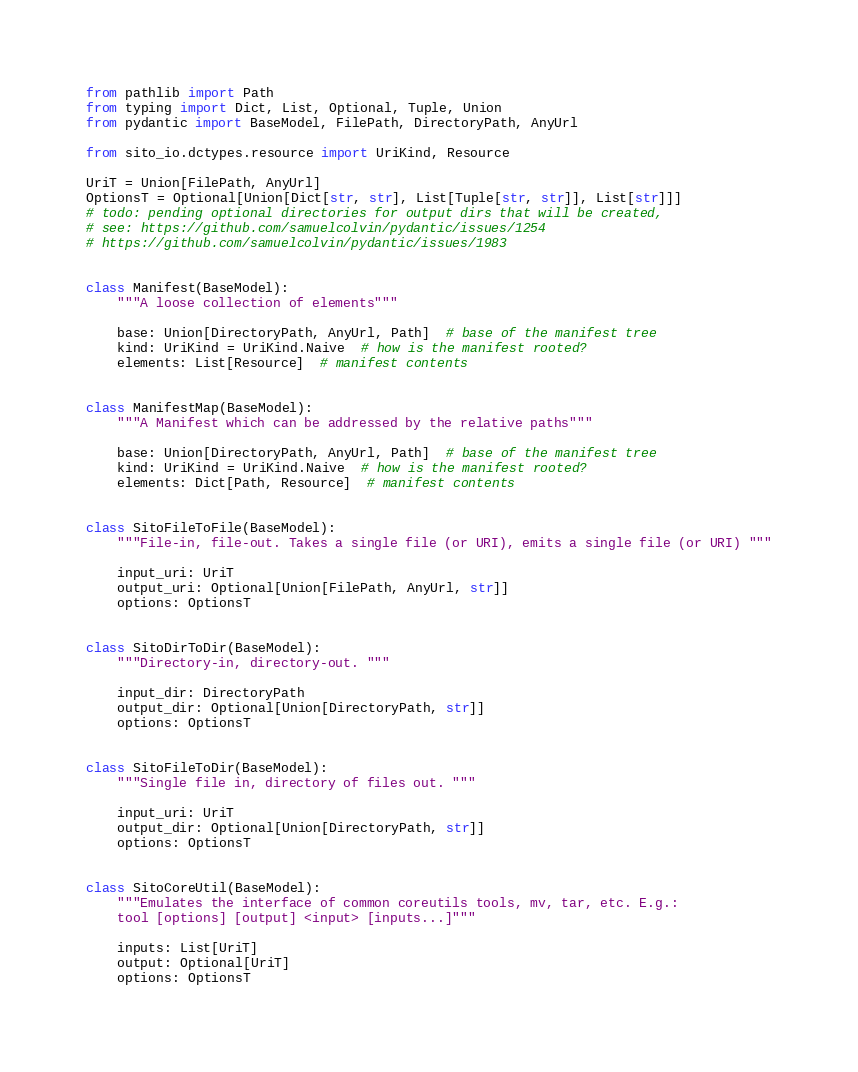Convert code to text. <code><loc_0><loc_0><loc_500><loc_500><_Python_>from pathlib import Path
from typing import Dict, List, Optional, Tuple, Union
from pydantic import BaseModel, FilePath, DirectoryPath, AnyUrl

from sito_io.dctypes.resource import UriKind, Resource

UriT = Union[FilePath, AnyUrl]
OptionsT = Optional[Union[Dict[str, str], List[Tuple[str, str]], List[str]]]
# todo: pending optional directories for output dirs that will be created,
# see: https://github.com/samuelcolvin/pydantic/issues/1254
# https://github.com/samuelcolvin/pydantic/issues/1983


class Manifest(BaseModel):
    """A loose collection of elements"""

    base: Union[DirectoryPath, AnyUrl, Path]  # base of the manifest tree
    kind: UriKind = UriKind.Naive  # how is the manifest rooted?
    elements: List[Resource]  # manifest contents


class ManifestMap(BaseModel):
    """A Manifest which can be addressed by the relative paths"""

    base: Union[DirectoryPath, AnyUrl, Path]  # base of the manifest tree
    kind: UriKind = UriKind.Naive  # how is the manifest rooted?
    elements: Dict[Path, Resource]  # manifest contents


class SitoFileToFile(BaseModel):
    """File-in, file-out. Takes a single file (or URI), emits a single file (or URI) """

    input_uri: UriT
    output_uri: Optional[Union[FilePath, AnyUrl, str]]
    options: OptionsT


class SitoDirToDir(BaseModel):
    """Directory-in, directory-out. """

    input_dir: DirectoryPath
    output_dir: Optional[Union[DirectoryPath, str]]
    options: OptionsT


class SitoFileToDir(BaseModel):
    """Single file in, directory of files out. """

    input_uri: UriT
    output_dir: Optional[Union[DirectoryPath, str]]
    options: OptionsT


class SitoCoreUtil(BaseModel):
    """Emulates the interface of common coreutils tools, mv, tar, etc. E.g.:
    tool [options] [output] <input> [inputs...]"""

    inputs: List[UriT]
    output: Optional[UriT]
    options: OptionsT
</code> 